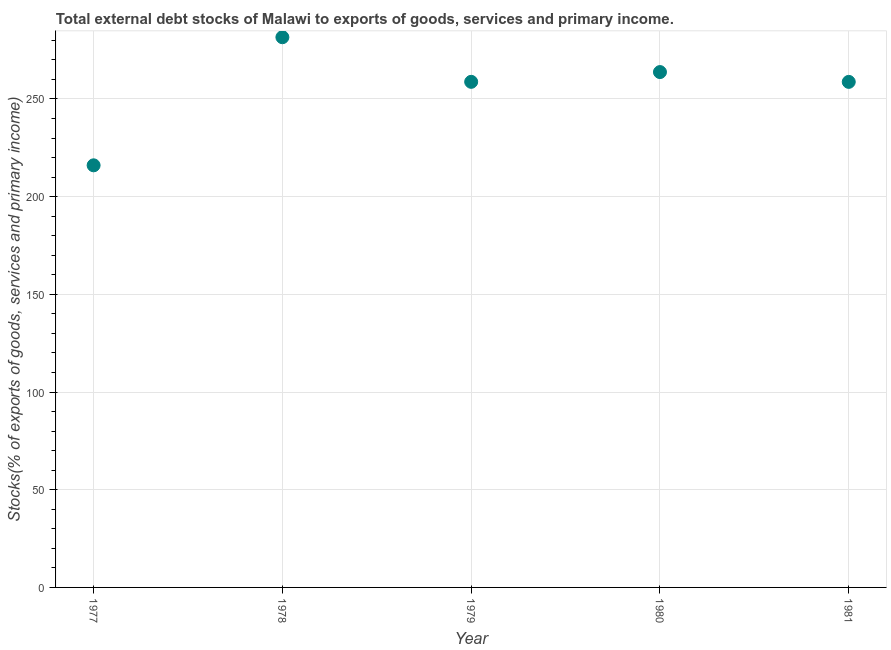What is the external debt stocks in 1978?
Provide a short and direct response. 281.57. Across all years, what is the maximum external debt stocks?
Your response must be concise. 281.57. Across all years, what is the minimum external debt stocks?
Your answer should be compact. 216.02. In which year was the external debt stocks maximum?
Provide a succinct answer. 1978. In which year was the external debt stocks minimum?
Provide a short and direct response. 1977. What is the sum of the external debt stocks?
Ensure brevity in your answer.  1278.8. What is the difference between the external debt stocks in 1978 and 1980?
Provide a succinct answer. 17.83. What is the average external debt stocks per year?
Your answer should be very brief. 255.76. What is the median external debt stocks?
Make the answer very short. 258.75. In how many years, is the external debt stocks greater than 100 %?
Provide a short and direct response. 5. Do a majority of the years between 1981 and 1979 (inclusive) have external debt stocks greater than 60 %?
Your answer should be compact. No. What is the ratio of the external debt stocks in 1979 to that in 1980?
Your response must be concise. 0.98. What is the difference between the highest and the second highest external debt stocks?
Offer a terse response. 17.83. Is the sum of the external debt stocks in 1980 and 1981 greater than the maximum external debt stocks across all years?
Offer a terse response. Yes. What is the difference between the highest and the lowest external debt stocks?
Provide a short and direct response. 65.55. How many dotlines are there?
Make the answer very short. 1. Does the graph contain grids?
Give a very brief answer. Yes. What is the title of the graph?
Provide a succinct answer. Total external debt stocks of Malawi to exports of goods, services and primary income. What is the label or title of the X-axis?
Your answer should be very brief. Year. What is the label or title of the Y-axis?
Your answer should be compact. Stocks(% of exports of goods, services and primary income). What is the Stocks(% of exports of goods, services and primary income) in 1977?
Ensure brevity in your answer.  216.02. What is the Stocks(% of exports of goods, services and primary income) in 1978?
Give a very brief answer. 281.57. What is the Stocks(% of exports of goods, services and primary income) in 1979?
Offer a terse response. 258.75. What is the Stocks(% of exports of goods, services and primary income) in 1980?
Make the answer very short. 263.74. What is the Stocks(% of exports of goods, services and primary income) in 1981?
Keep it short and to the point. 258.72. What is the difference between the Stocks(% of exports of goods, services and primary income) in 1977 and 1978?
Your answer should be very brief. -65.55. What is the difference between the Stocks(% of exports of goods, services and primary income) in 1977 and 1979?
Offer a terse response. -42.73. What is the difference between the Stocks(% of exports of goods, services and primary income) in 1977 and 1980?
Your answer should be compact. -47.72. What is the difference between the Stocks(% of exports of goods, services and primary income) in 1977 and 1981?
Your answer should be compact. -42.7. What is the difference between the Stocks(% of exports of goods, services and primary income) in 1978 and 1979?
Keep it short and to the point. 22.83. What is the difference between the Stocks(% of exports of goods, services and primary income) in 1978 and 1980?
Make the answer very short. 17.83. What is the difference between the Stocks(% of exports of goods, services and primary income) in 1978 and 1981?
Your answer should be compact. 22.85. What is the difference between the Stocks(% of exports of goods, services and primary income) in 1979 and 1980?
Provide a short and direct response. -5. What is the difference between the Stocks(% of exports of goods, services and primary income) in 1979 and 1981?
Keep it short and to the point. 0.03. What is the difference between the Stocks(% of exports of goods, services and primary income) in 1980 and 1981?
Your response must be concise. 5.02. What is the ratio of the Stocks(% of exports of goods, services and primary income) in 1977 to that in 1978?
Your response must be concise. 0.77. What is the ratio of the Stocks(% of exports of goods, services and primary income) in 1977 to that in 1979?
Your answer should be very brief. 0.83. What is the ratio of the Stocks(% of exports of goods, services and primary income) in 1977 to that in 1980?
Your answer should be very brief. 0.82. What is the ratio of the Stocks(% of exports of goods, services and primary income) in 1977 to that in 1981?
Offer a terse response. 0.83. What is the ratio of the Stocks(% of exports of goods, services and primary income) in 1978 to that in 1979?
Offer a very short reply. 1.09. What is the ratio of the Stocks(% of exports of goods, services and primary income) in 1978 to that in 1980?
Offer a terse response. 1.07. What is the ratio of the Stocks(% of exports of goods, services and primary income) in 1978 to that in 1981?
Keep it short and to the point. 1.09. What is the ratio of the Stocks(% of exports of goods, services and primary income) in 1979 to that in 1980?
Give a very brief answer. 0.98. What is the ratio of the Stocks(% of exports of goods, services and primary income) in 1979 to that in 1981?
Provide a succinct answer. 1. What is the ratio of the Stocks(% of exports of goods, services and primary income) in 1980 to that in 1981?
Offer a very short reply. 1.02. 